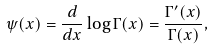<formula> <loc_0><loc_0><loc_500><loc_500>\psi ( x ) = \frac { d } { d x } \log \Gamma ( x ) = \frac { \Gamma ^ { \prime } ( x ) } { \Gamma ( x ) } ,</formula> 